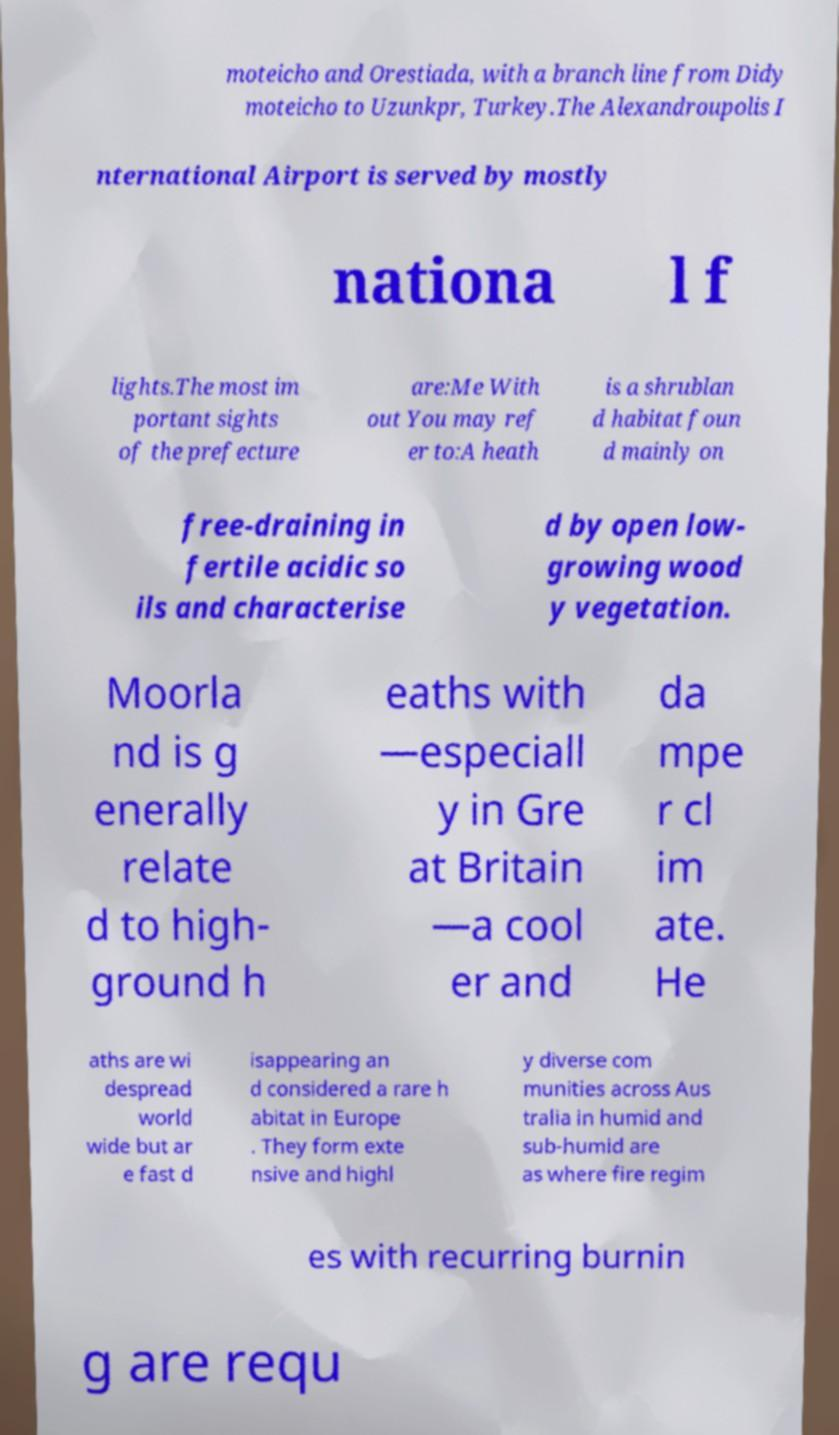Please read and relay the text visible in this image. What does it say? moteicho and Orestiada, with a branch line from Didy moteicho to Uzunkpr, Turkey.The Alexandroupolis I nternational Airport is served by mostly nationa l f lights.The most im portant sights of the prefecture are:Me With out You may ref er to:A heath is a shrublan d habitat foun d mainly on free-draining in fertile acidic so ils and characterise d by open low- growing wood y vegetation. Moorla nd is g enerally relate d to high- ground h eaths with —especiall y in Gre at Britain —a cool er and da mpe r cl im ate. He aths are wi despread world wide but ar e fast d isappearing an d considered a rare h abitat in Europe . They form exte nsive and highl y diverse com munities across Aus tralia in humid and sub-humid are as where fire regim es with recurring burnin g are requ 